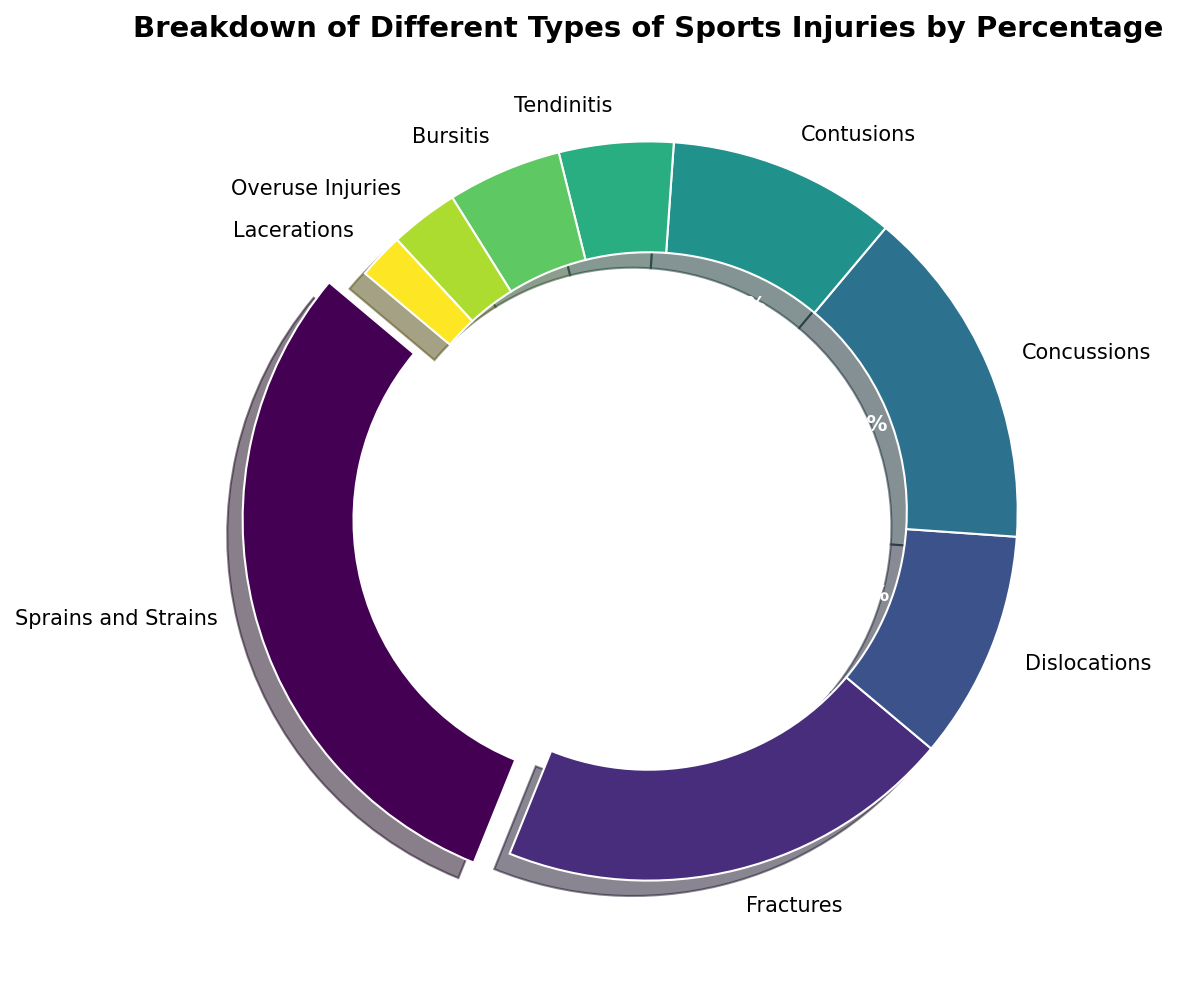What's the most common type of sports injury? The slice with the largest percentage represents the most common type of injury. From the chart, "Sprains and Strains" has the largest slice at 30%.
Answer: Sprains and Strains Which injury has the second highest percentage? The slice that is largest after "Sprains and Strains" is "Fractures," which has a 20% share.
Answer: Fractures How much more common are sprains and strains compared to contusions? To find how much more common sprains and strains are, subtract the percentage of contusions (10%) from the percentage of sprains and strains (30%). Thus, 30% - 10% = 20%.
Answer: 20% What is the combined percentage of concussions and dislocations? Add the percentages of concussions (15%) and dislocations (10%). 15% + 10% = 25%.
Answer: 25% Which injuries have the same percentage and what are they? Identifying slices with the same size, both tendinitis and bursitis have equal percentages at 5%.
Answer: Tendinitis and Bursitis Which injury occupies the smallest part of the chart? The smallest slice in the chart corresponds to the injury type with only 2%, which is "Lacerations."
Answer: Lacerations Are dislocations more or less common than fractures? By comparing the percentages, dislocations have 10% while fractures have 20%. Dislocations are less common than fractures.
Answer: Less common What is the total percentage of overuse injuries, lacerations, and bursitis? Adding their percentages: Overuse Injuries (3%) + Lacerations (2%) + Bursitis (5%) gives: 3% + 2% + 5% = 10%.
Answer: 10% If sprains and strains and fractures are combined, what percentage of total injuries do they represent? Adding the percentages of sprains and strains (30%) and fractures (20%) gives 30% + 20% = 50%.
Answer: 50% Which injury type represents a middle ground (50th percentile) when the injury types are ordered by percentage? Ordering the injuries by percentage, Sprains and Strains (30%), Fractures (20%), Concussions (15%), Dislocations (10%), Contusions (10%), Tendinitis (5%), Bursitis (5%), Overuse Injuries (3%), and Lacerations (2%): the middle ground or 50th percentile lies between Concussions (15%) and Dislocations (10%).
Answer: Concussions and Dislocations 